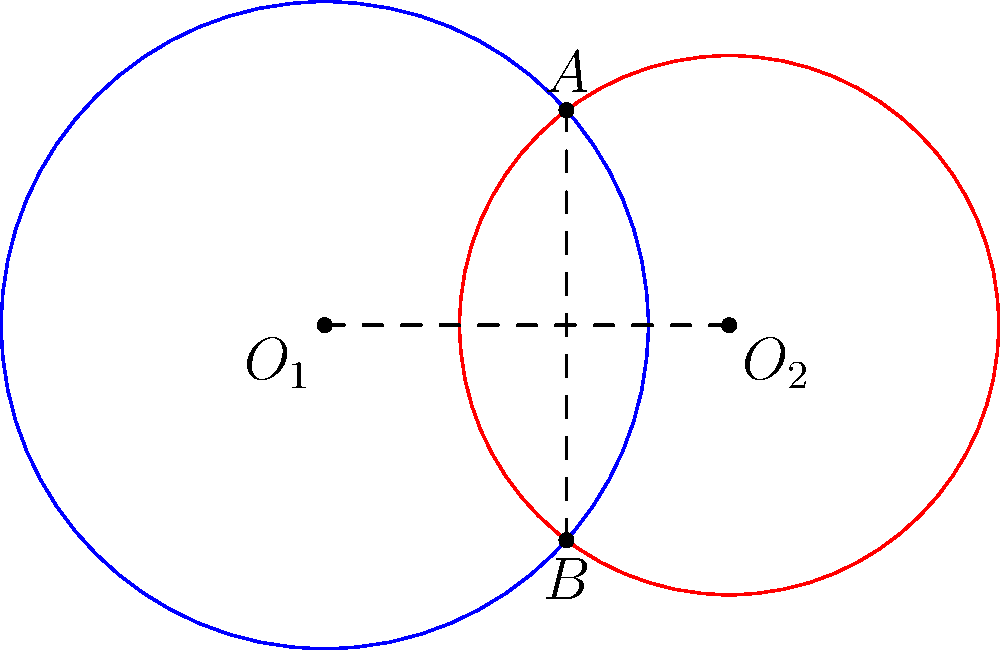In your celestial studies, you observe two overlapping circular orbits of celestial bodies. The centers of these orbits, $O_1$ and $O_2$, are 1.5 units apart. The radius of the first orbit is 1.2 units, while the second orbit has a radius of 1 unit. What is the length of the common chord $AB$ formed by the intersection of these two orbits? Let's approach this step-by-step:

1) First, we need to find the distance between the intersection points A and B. This can be done using the formula for the length of a common chord between two intersecting circles.

2) The formula for the length of the common chord is:
   $$AB = 2\sqrt{\frac{(-d+a+b)(d+a-b)(d-a+b)(d+a+b)}{4d^2}}$$
   where $d$ is the distance between the centers, and $a$ and $b$ are the radii of the two circles.

3) We're given:
   $d = 1.5$ (distance between $O_1$ and $O_2$)
   $a = 1.2$ (radius of the first orbit)
   $b = 1$ (radius of the second orbit)

4) Let's substitute these values into our formula:
   $$AB = 2\sqrt{\frac{(-1.5+1.2+1)(1.5+1.2-1)(1.5-1.2+1)(1.5+1.2+1)}{4(1.5)^2}}$$

5) Simplify inside the parentheses:
   $$AB = 2\sqrt{\frac{(0.7)(1.7)(1.3)(3.7)}{9}}$$

6) Multiply the numbers inside the parentheses:
   $$AB = 2\sqrt{\frac{5.9943}{9}}$$

7) Divide inside the square root:
   $$AB = 2\sqrt{0.6660} \approx 2(0.8162) \approx 1.6324$$

Therefore, the length of the common chord AB is approximately 1.6324 units.
Answer: $1.6324$ units 